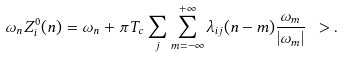<formula> <loc_0><loc_0><loc_500><loc_500>\omega _ { n } Z _ { i } ^ { 0 } ( n ) = \omega _ { n } + \pi T _ { c } \sum _ { j } \sum _ { m = - \infty } ^ { + \infty } \lambda _ { i j } ( n - m ) \frac { \omega _ { m } } { | \omega _ { m } | } \ > .</formula> 